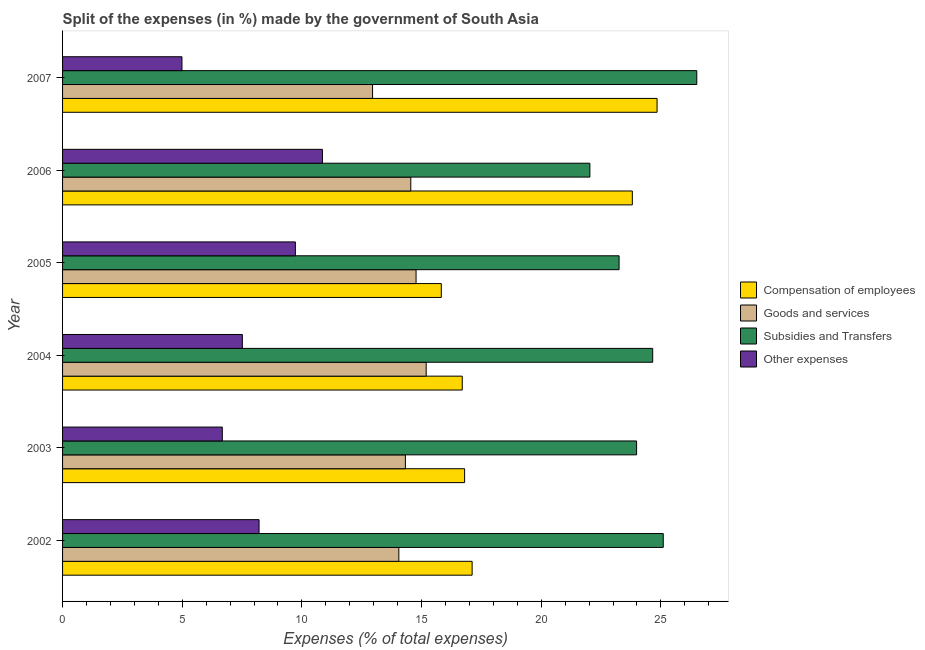How many different coloured bars are there?
Ensure brevity in your answer.  4. Are the number of bars per tick equal to the number of legend labels?
Keep it short and to the point. Yes. How many bars are there on the 3rd tick from the top?
Your answer should be compact. 4. In how many cases, is the number of bars for a given year not equal to the number of legend labels?
Ensure brevity in your answer.  0. What is the percentage of amount spent on goods and services in 2003?
Offer a very short reply. 14.32. Across all years, what is the maximum percentage of amount spent on subsidies?
Your answer should be compact. 26.5. Across all years, what is the minimum percentage of amount spent on compensation of employees?
Offer a very short reply. 15.82. In which year was the percentage of amount spent on compensation of employees maximum?
Make the answer very short. 2007. In which year was the percentage of amount spent on subsidies minimum?
Provide a succinct answer. 2006. What is the total percentage of amount spent on subsidies in the graph?
Provide a succinct answer. 145.52. What is the difference between the percentage of amount spent on goods and services in 2004 and that in 2006?
Ensure brevity in your answer.  0.64. What is the difference between the percentage of amount spent on subsidies in 2006 and the percentage of amount spent on other expenses in 2002?
Ensure brevity in your answer.  13.82. What is the average percentage of amount spent on other expenses per year?
Your answer should be compact. 8. In the year 2007, what is the difference between the percentage of amount spent on compensation of employees and percentage of amount spent on other expenses?
Provide a short and direct response. 19.85. What is the ratio of the percentage of amount spent on subsidies in 2004 to that in 2005?
Your answer should be very brief. 1.06. What is the difference between the highest and the second highest percentage of amount spent on other expenses?
Provide a short and direct response. 1.13. What is the difference between the highest and the lowest percentage of amount spent on subsidies?
Your answer should be very brief. 4.47. Is the sum of the percentage of amount spent on goods and services in 2006 and 2007 greater than the maximum percentage of amount spent on subsidies across all years?
Make the answer very short. Yes. Is it the case that in every year, the sum of the percentage of amount spent on goods and services and percentage of amount spent on subsidies is greater than the sum of percentage of amount spent on compensation of employees and percentage of amount spent on other expenses?
Your response must be concise. No. What does the 3rd bar from the top in 2002 represents?
Provide a short and direct response. Goods and services. What does the 4th bar from the bottom in 2002 represents?
Give a very brief answer. Other expenses. Is it the case that in every year, the sum of the percentage of amount spent on compensation of employees and percentage of amount spent on goods and services is greater than the percentage of amount spent on subsidies?
Make the answer very short. Yes. Are all the bars in the graph horizontal?
Provide a short and direct response. Yes. How many years are there in the graph?
Make the answer very short. 6. Does the graph contain any zero values?
Keep it short and to the point. No. Does the graph contain grids?
Offer a terse response. No. How are the legend labels stacked?
Ensure brevity in your answer.  Vertical. What is the title of the graph?
Offer a very short reply. Split of the expenses (in %) made by the government of South Asia. What is the label or title of the X-axis?
Keep it short and to the point. Expenses (% of total expenses). What is the Expenses (% of total expenses) of Compensation of employees in 2002?
Offer a very short reply. 17.11. What is the Expenses (% of total expenses) of Goods and services in 2002?
Provide a short and direct response. 14.05. What is the Expenses (% of total expenses) of Subsidies and Transfers in 2002?
Give a very brief answer. 25.1. What is the Expenses (% of total expenses) in Other expenses in 2002?
Provide a succinct answer. 8.21. What is the Expenses (% of total expenses) in Compensation of employees in 2003?
Offer a terse response. 16.8. What is the Expenses (% of total expenses) in Goods and services in 2003?
Ensure brevity in your answer.  14.32. What is the Expenses (% of total expenses) in Subsidies and Transfers in 2003?
Give a very brief answer. 23.98. What is the Expenses (% of total expenses) of Other expenses in 2003?
Keep it short and to the point. 6.67. What is the Expenses (% of total expenses) in Compensation of employees in 2004?
Provide a succinct answer. 16.7. What is the Expenses (% of total expenses) of Goods and services in 2004?
Offer a very short reply. 15.19. What is the Expenses (% of total expenses) in Subsidies and Transfers in 2004?
Keep it short and to the point. 24.66. What is the Expenses (% of total expenses) of Other expenses in 2004?
Make the answer very short. 7.51. What is the Expenses (% of total expenses) in Compensation of employees in 2005?
Provide a succinct answer. 15.82. What is the Expenses (% of total expenses) of Goods and services in 2005?
Make the answer very short. 14.77. What is the Expenses (% of total expenses) of Subsidies and Transfers in 2005?
Provide a succinct answer. 23.25. What is the Expenses (% of total expenses) of Other expenses in 2005?
Offer a very short reply. 9.73. What is the Expenses (% of total expenses) in Compensation of employees in 2006?
Offer a very short reply. 23.81. What is the Expenses (% of total expenses) in Goods and services in 2006?
Your response must be concise. 14.55. What is the Expenses (% of total expenses) in Subsidies and Transfers in 2006?
Provide a succinct answer. 22.03. What is the Expenses (% of total expenses) in Other expenses in 2006?
Your answer should be compact. 10.86. What is the Expenses (% of total expenses) of Compensation of employees in 2007?
Make the answer very short. 24.84. What is the Expenses (% of total expenses) in Goods and services in 2007?
Your answer should be compact. 12.95. What is the Expenses (% of total expenses) in Subsidies and Transfers in 2007?
Your response must be concise. 26.5. What is the Expenses (% of total expenses) in Other expenses in 2007?
Offer a very short reply. 4.99. Across all years, what is the maximum Expenses (% of total expenses) of Compensation of employees?
Your response must be concise. 24.84. Across all years, what is the maximum Expenses (% of total expenses) of Goods and services?
Provide a succinct answer. 15.19. Across all years, what is the maximum Expenses (% of total expenses) in Subsidies and Transfers?
Provide a short and direct response. 26.5. Across all years, what is the maximum Expenses (% of total expenses) in Other expenses?
Provide a succinct answer. 10.86. Across all years, what is the minimum Expenses (% of total expenses) of Compensation of employees?
Give a very brief answer. 15.82. Across all years, what is the minimum Expenses (% of total expenses) in Goods and services?
Offer a very short reply. 12.95. Across all years, what is the minimum Expenses (% of total expenses) of Subsidies and Transfers?
Make the answer very short. 22.03. Across all years, what is the minimum Expenses (% of total expenses) of Other expenses?
Give a very brief answer. 4.99. What is the total Expenses (% of total expenses) of Compensation of employees in the graph?
Offer a terse response. 115.08. What is the total Expenses (% of total expenses) in Goods and services in the graph?
Give a very brief answer. 85.84. What is the total Expenses (% of total expenses) of Subsidies and Transfers in the graph?
Give a very brief answer. 145.52. What is the total Expenses (% of total expenses) of Other expenses in the graph?
Your response must be concise. 47.97. What is the difference between the Expenses (% of total expenses) of Compensation of employees in 2002 and that in 2003?
Provide a succinct answer. 0.31. What is the difference between the Expenses (% of total expenses) of Goods and services in 2002 and that in 2003?
Keep it short and to the point. -0.27. What is the difference between the Expenses (% of total expenses) in Subsidies and Transfers in 2002 and that in 2003?
Make the answer very short. 1.11. What is the difference between the Expenses (% of total expenses) of Other expenses in 2002 and that in 2003?
Offer a very short reply. 1.54. What is the difference between the Expenses (% of total expenses) of Compensation of employees in 2002 and that in 2004?
Keep it short and to the point. 0.41. What is the difference between the Expenses (% of total expenses) of Goods and services in 2002 and that in 2004?
Your answer should be compact. -1.14. What is the difference between the Expenses (% of total expenses) in Subsidies and Transfers in 2002 and that in 2004?
Provide a succinct answer. 0.44. What is the difference between the Expenses (% of total expenses) of Other expenses in 2002 and that in 2004?
Make the answer very short. 0.7. What is the difference between the Expenses (% of total expenses) of Compensation of employees in 2002 and that in 2005?
Your answer should be very brief. 1.29. What is the difference between the Expenses (% of total expenses) in Goods and services in 2002 and that in 2005?
Your response must be concise. -0.72. What is the difference between the Expenses (% of total expenses) in Subsidies and Transfers in 2002 and that in 2005?
Make the answer very short. 1.84. What is the difference between the Expenses (% of total expenses) in Other expenses in 2002 and that in 2005?
Make the answer very short. -1.52. What is the difference between the Expenses (% of total expenses) in Compensation of employees in 2002 and that in 2006?
Ensure brevity in your answer.  -6.69. What is the difference between the Expenses (% of total expenses) of Goods and services in 2002 and that in 2006?
Provide a short and direct response. -0.5. What is the difference between the Expenses (% of total expenses) of Subsidies and Transfers in 2002 and that in 2006?
Your answer should be compact. 3.07. What is the difference between the Expenses (% of total expenses) in Other expenses in 2002 and that in 2006?
Your answer should be very brief. -2.65. What is the difference between the Expenses (% of total expenses) of Compensation of employees in 2002 and that in 2007?
Ensure brevity in your answer.  -7.73. What is the difference between the Expenses (% of total expenses) in Goods and services in 2002 and that in 2007?
Your answer should be very brief. 1.1. What is the difference between the Expenses (% of total expenses) of Subsidies and Transfers in 2002 and that in 2007?
Ensure brevity in your answer.  -1.4. What is the difference between the Expenses (% of total expenses) of Other expenses in 2002 and that in 2007?
Make the answer very short. 3.22. What is the difference between the Expenses (% of total expenses) in Compensation of employees in 2003 and that in 2004?
Offer a terse response. 0.1. What is the difference between the Expenses (% of total expenses) in Goods and services in 2003 and that in 2004?
Ensure brevity in your answer.  -0.87. What is the difference between the Expenses (% of total expenses) of Subsidies and Transfers in 2003 and that in 2004?
Ensure brevity in your answer.  -0.67. What is the difference between the Expenses (% of total expenses) in Other expenses in 2003 and that in 2004?
Your answer should be compact. -0.84. What is the difference between the Expenses (% of total expenses) of Compensation of employees in 2003 and that in 2005?
Keep it short and to the point. 0.97. What is the difference between the Expenses (% of total expenses) of Goods and services in 2003 and that in 2005?
Your response must be concise. -0.45. What is the difference between the Expenses (% of total expenses) of Subsidies and Transfers in 2003 and that in 2005?
Give a very brief answer. 0.73. What is the difference between the Expenses (% of total expenses) of Other expenses in 2003 and that in 2005?
Ensure brevity in your answer.  -3.05. What is the difference between the Expenses (% of total expenses) of Compensation of employees in 2003 and that in 2006?
Keep it short and to the point. -7.01. What is the difference between the Expenses (% of total expenses) of Goods and services in 2003 and that in 2006?
Offer a terse response. -0.23. What is the difference between the Expenses (% of total expenses) in Subsidies and Transfers in 2003 and that in 2006?
Your answer should be very brief. 1.95. What is the difference between the Expenses (% of total expenses) of Other expenses in 2003 and that in 2006?
Your answer should be very brief. -4.18. What is the difference between the Expenses (% of total expenses) in Compensation of employees in 2003 and that in 2007?
Your answer should be compact. -8.04. What is the difference between the Expenses (% of total expenses) in Goods and services in 2003 and that in 2007?
Keep it short and to the point. 1.37. What is the difference between the Expenses (% of total expenses) in Subsidies and Transfers in 2003 and that in 2007?
Make the answer very short. -2.52. What is the difference between the Expenses (% of total expenses) of Other expenses in 2003 and that in 2007?
Ensure brevity in your answer.  1.69. What is the difference between the Expenses (% of total expenses) of Compensation of employees in 2004 and that in 2005?
Offer a very short reply. 0.88. What is the difference between the Expenses (% of total expenses) of Goods and services in 2004 and that in 2005?
Your answer should be very brief. 0.42. What is the difference between the Expenses (% of total expenses) of Subsidies and Transfers in 2004 and that in 2005?
Offer a very short reply. 1.4. What is the difference between the Expenses (% of total expenses) of Other expenses in 2004 and that in 2005?
Give a very brief answer. -2.22. What is the difference between the Expenses (% of total expenses) of Compensation of employees in 2004 and that in 2006?
Keep it short and to the point. -7.11. What is the difference between the Expenses (% of total expenses) of Goods and services in 2004 and that in 2006?
Ensure brevity in your answer.  0.64. What is the difference between the Expenses (% of total expenses) of Subsidies and Transfers in 2004 and that in 2006?
Give a very brief answer. 2.63. What is the difference between the Expenses (% of total expenses) in Other expenses in 2004 and that in 2006?
Keep it short and to the point. -3.35. What is the difference between the Expenses (% of total expenses) of Compensation of employees in 2004 and that in 2007?
Offer a very short reply. -8.14. What is the difference between the Expenses (% of total expenses) of Goods and services in 2004 and that in 2007?
Give a very brief answer. 2.24. What is the difference between the Expenses (% of total expenses) of Subsidies and Transfers in 2004 and that in 2007?
Your answer should be very brief. -1.84. What is the difference between the Expenses (% of total expenses) in Other expenses in 2004 and that in 2007?
Your answer should be compact. 2.52. What is the difference between the Expenses (% of total expenses) in Compensation of employees in 2005 and that in 2006?
Offer a very short reply. -7.98. What is the difference between the Expenses (% of total expenses) in Goods and services in 2005 and that in 2006?
Provide a short and direct response. 0.22. What is the difference between the Expenses (% of total expenses) in Subsidies and Transfers in 2005 and that in 2006?
Your answer should be compact. 1.22. What is the difference between the Expenses (% of total expenses) of Other expenses in 2005 and that in 2006?
Make the answer very short. -1.13. What is the difference between the Expenses (% of total expenses) in Compensation of employees in 2005 and that in 2007?
Provide a succinct answer. -9.02. What is the difference between the Expenses (% of total expenses) in Goods and services in 2005 and that in 2007?
Give a very brief answer. 1.82. What is the difference between the Expenses (% of total expenses) in Subsidies and Transfers in 2005 and that in 2007?
Your response must be concise. -3.25. What is the difference between the Expenses (% of total expenses) of Other expenses in 2005 and that in 2007?
Your response must be concise. 4.74. What is the difference between the Expenses (% of total expenses) of Compensation of employees in 2006 and that in 2007?
Provide a succinct answer. -1.03. What is the difference between the Expenses (% of total expenses) in Goods and services in 2006 and that in 2007?
Offer a very short reply. 1.6. What is the difference between the Expenses (% of total expenses) of Subsidies and Transfers in 2006 and that in 2007?
Provide a succinct answer. -4.47. What is the difference between the Expenses (% of total expenses) of Other expenses in 2006 and that in 2007?
Your response must be concise. 5.87. What is the difference between the Expenses (% of total expenses) of Compensation of employees in 2002 and the Expenses (% of total expenses) of Goods and services in 2003?
Ensure brevity in your answer.  2.79. What is the difference between the Expenses (% of total expenses) of Compensation of employees in 2002 and the Expenses (% of total expenses) of Subsidies and Transfers in 2003?
Your answer should be very brief. -6.87. What is the difference between the Expenses (% of total expenses) in Compensation of employees in 2002 and the Expenses (% of total expenses) in Other expenses in 2003?
Provide a short and direct response. 10.44. What is the difference between the Expenses (% of total expenses) of Goods and services in 2002 and the Expenses (% of total expenses) of Subsidies and Transfers in 2003?
Your response must be concise. -9.93. What is the difference between the Expenses (% of total expenses) of Goods and services in 2002 and the Expenses (% of total expenses) of Other expenses in 2003?
Make the answer very short. 7.38. What is the difference between the Expenses (% of total expenses) in Subsidies and Transfers in 2002 and the Expenses (% of total expenses) in Other expenses in 2003?
Provide a succinct answer. 18.42. What is the difference between the Expenses (% of total expenses) of Compensation of employees in 2002 and the Expenses (% of total expenses) of Goods and services in 2004?
Offer a very short reply. 1.92. What is the difference between the Expenses (% of total expenses) of Compensation of employees in 2002 and the Expenses (% of total expenses) of Subsidies and Transfers in 2004?
Give a very brief answer. -7.54. What is the difference between the Expenses (% of total expenses) in Compensation of employees in 2002 and the Expenses (% of total expenses) in Other expenses in 2004?
Your response must be concise. 9.6. What is the difference between the Expenses (% of total expenses) of Goods and services in 2002 and the Expenses (% of total expenses) of Subsidies and Transfers in 2004?
Offer a very short reply. -10.61. What is the difference between the Expenses (% of total expenses) of Goods and services in 2002 and the Expenses (% of total expenses) of Other expenses in 2004?
Provide a succinct answer. 6.54. What is the difference between the Expenses (% of total expenses) of Subsidies and Transfers in 2002 and the Expenses (% of total expenses) of Other expenses in 2004?
Ensure brevity in your answer.  17.59. What is the difference between the Expenses (% of total expenses) of Compensation of employees in 2002 and the Expenses (% of total expenses) of Goods and services in 2005?
Keep it short and to the point. 2.34. What is the difference between the Expenses (% of total expenses) in Compensation of employees in 2002 and the Expenses (% of total expenses) in Subsidies and Transfers in 2005?
Provide a short and direct response. -6.14. What is the difference between the Expenses (% of total expenses) in Compensation of employees in 2002 and the Expenses (% of total expenses) in Other expenses in 2005?
Provide a short and direct response. 7.38. What is the difference between the Expenses (% of total expenses) of Goods and services in 2002 and the Expenses (% of total expenses) of Subsidies and Transfers in 2005?
Your response must be concise. -9.2. What is the difference between the Expenses (% of total expenses) in Goods and services in 2002 and the Expenses (% of total expenses) in Other expenses in 2005?
Give a very brief answer. 4.32. What is the difference between the Expenses (% of total expenses) in Subsidies and Transfers in 2002 and the Expenses (% of total expenses) in Other expenses in 2005?
Your answer should be very brief. 15.37. What is the difference between the Expenses (% of total expenses) in Compensation of employees in 2002 and the Expenses (% of total expenses) in Goods and services in 2006?
Offer a very short reply. 2.56. What is the difference between the Expenses (% of total expenses) of Compensation of employees in 2002 and the Expenses (% of total expenses) of Subsidies and Transfers in 2006?
Offer a very short reply. -4.92. What is the difference between the Expenses (% of total expenses) of Compensation of employees in 2002 and the Expenses (% of total expenses) of Other expenses in 2006?
Provide a short and direct response. 6.25. What is the difference between the Expenses (% of total expenses) of Goods and services in 2002 and the Expenses (% of total expenses) of Subsidies and Transfers in 2006?
Offer a terse response. -7.98. What is the difference between the Expenses (% of total expenses) of Goods and services in 2002 and the Expenses (% of total expenses) of Other expenses in 2006?
Keep it short and to the point. 3.19. What is the difference between the Expenses (% of total expenses) of Subsidies and Transfers in 2002 and the Expenses (% of total expenses) of Other expenses in 2006?
Give a very brief answer. 14.24. What is the difference between the Expenses (% of total expenses) of Compensation of employees in 2002 and the Expenses (% of total expenses) of Goods and services in 2007?
Your answer should be compact. 4.16. What is the difference between the Expenses (% of total expenses) in Compensation of employees in 2002 and the Expenses (% of total expenses) in Subsidies and Transfers in 2007?
Provide a succinct answer. -9.39. What is the difference between the Expenses (% of total expenses) in Compensation of employees in 2002 and the Expenses (% of total expenses) in Other expenses in 2007?
Offer a terse response. 12.12. What is the difference between the Expenses (% of total expenses) of Goods and services in 2002 and the Expenses (% of total expenses) of Subsidies and Transfers in 2007?
Offer a very short reply. -12.45. What is the difference between the Expenses (% of total expenses) of Goods and services in 2002 and the Expenses (% of total expenses) of Other expenses in 2007?
Provide a short and direct response. 9.06. What is the difference between the Expenses (% of total expenses) of Subsidies and Transfers in 2002 and the Expenses (% of total expenses) of Other expenses in 2007?
Provide a succinct answer. 20.11. What is the difference between the Expenses (% of total expenses) of Compensation of employees in 2003 and the Expenses (% of total expenses) of Goods and services in 2004?
Ensure brevity in your answer.  1.6. What is the difference between the Expenses (% of total expenses) in Compensation of employees in 2003 and the Expenses (% of total expenses) in Subsidies and Transfers in 2004?
Ensure brevity in your answer.  -7.86. What is the difference between the Expenses (% of total expenses) in Compensation of employees in 2003 and the Expenses (% of total expenses) in Other expenses in 2004?
Your response must be concise. 9.29. What is the difference between the Expenses (% of total expenses) of Goods and services in 2003 and the Expenses (% of total expenses) of Subsidies and Transfers in 2004?
Ensure brevity in your answer.  -10.33. What is the difference between the Expenses (% of total expenses) in Goods and services in 2003 and the Expenses (% of total expenses) in Other expenses in 2004?
Offer a terse response. 6.81. What is the difference between the Expenses (% of total expenses) in Subsidies and Transfers in 2003 and the Expenses (% of total expenses) in Other expenses in 2004?
Provide a succinct answer. 16.47. What is the difference between the Expenses (% of total expenses) of Compensation of employees in 2003 and the Expenses (% of total expenses) of Goods and services in 2005?
Ensure brevity in your answer.  2.03. What is the difference between the Expenses (% of total expenses) in Compensation of employees in 2003 and the Expenses (% of total expenses) in Subsidies and Transfers in 2005?
Your response must be concise. -6.45. What is the difference between the Expenses (% of total expenses) in Compensation of employees in 2003 and the Expenses (% of total expenses) in Other expenses in 2005?
Give a very brief answer. 7.07. What is the difference between the Expenses (% of total expenses) in Goods and services in 2003 and the Expenses (% of total expenses) in Subsidies and Transfers in 2005?
Offer a terse response. -8.93. What is the difference between the Expenses (% of total expenses) in Goods and services in 2003 and the Expenses (% of total expenses) in Other expenses in 2005?
Offer a terse response. 4.6. What is the difference between the Expenses (% of total expenses) in Subsidies and Transfers in 2003 and the Expenses (% of total expenses) in Other expenses in 2005?
Offer a terse response. 14.26. What is the difference between the Expenses (% of total expenses) in Compensation of employees in 2003 and the Expenses (% of total expenses) in Goods and services in 2006?
Your answer should be very brief. 2.25. What is the difference between the Expenses (% of total expenses) of Compensation of employees in 2003 and the Expenses (% of total expenses) of Subsidies and Transfers in 2006?
Your answer should be compact. -5.23. What is the difference between the Expenses (% of total expenses) in Compensation of employees in 2003 and the Expenses (% of total expenses) in Other expenses in 2006?
Provide a succinct answer. 5.94. What is the difference between the Expenses (% of total expenses) of Goods and services in 2003 and the Expenses (% of total expenses) of Subsidies and Transfers in 2006?
Ensure brevity in your answer.  -7.71. What is the difference between the Expenses (% of total expenses) of Goods and services in 2003 and the Expenses (% of total expenses) of Other expenses in 2006?
Provide a short and direct response. 3.47. What is the difference between the Expenses (% of total expenses) in Subsidies and Transfers in 2003 and the Expenses (% of total expenses) in Other expenses in 2006?
Your answer should be very brief. 13.12. What is the difference between the Expenses (% of total expenses) of Compensation of employees in 2003 and the Expenses (% of total expenses) of Goods and services in 2007?
Provide a succinct answer. 3.85. What is the difference between the Expenses (% of total expenses) in Compensation of employees in 2003 and the Expenses (% of total expenses) in Subsidies and Transfers in 2007?
Offer a terse response. -9.7. What is the difference between the Expenses (% of total expenses) in Compensation of employees in 2003 and the Expenses (% of total expenses) in Other expenses in 2007?
Your response must be concise. 11.81. What is the difference between the Expenses (% of total expenses) in Goods and services in 2003 and the Expenses (% of total expenses) in Subsidies and Transfers in 2007?
Provide a succinct answer. -12.18. What is the difference between the Expenses (% of total expenses) in Goods and services in 2003 and the Expenses (% of total expenses) in Other expenses in 2007?
Give a very brief answer. 9.34. What is the difference between the Expenses (% of total expenses) of Subsidies and Transfers in 2003 and the Expenses (% of total expenses) of Other expenses in 2007?
Keep it short and to the point. 19. What is the difference between the Expenses (% of total expenses) of Compensation of employees in 2004 and the Expenses (% of total expenses) of Goods and services in 2005?
Offer a very short reply. 1.93. What is the difference between the Expenses (% of total expenses) in Compensation of employees in 2004 and the Expenses (% of total expenses) in Subsidies and Transfers in 2005?
Your answer should be compact. -6.55. What is the difference between the Expenses (% of total expenses) in Compensation of employees in 2004 and the Expenses (% of total expenses) in Other expenses in 2005?
Ensure brevity in your answer.  6.97. What is the difference between the Expenses (% of total expenses) of Goods and services in 2004 and the Expenses (% of total expenses) of Subsidies and Transfers in 2005?
Ensure brevity in your answer.  -8.06. What is the difference between the Expenses (% of total expenses) in Goods and services in 2004 and the Expenses (% of total expenses) in Other expenses in 2005?
Your response must be concise. 5.47. What is the difference between the Expenses (% of total expenses) in Subsidies and Transfers in 2004 and the Expenses (% of total expenses) in Other expenses in 2005?
Keep it short and to the point. 14.93. What is the difference between the Expenses (% of total expenses) in Compensation of employees in 2004 and the Expenses (% of total expenses) in Goods and services in 2006?
Your response must be concise. 2.15. What is the difference between the Expenses (% of total expenses) in Compensation of employees in 2004 and the Expenses (% of total expenses) in Subsidies and Transfers in 2006?
Offer a terse response. -5.33. What is the difference between the Expenses (% of total expenses) of Compensation of employees in 2004 and the Expenses (% of total expenses) of Other expenses in 2006?
Give a very brief answer. 5.84. What is the difference between the Expenses (% of total expenses) of Goods and services in 2004 and the Expenses (% of total expenses) of Subsidies and Transfers in 2006?
Your answer should be very brief. -6.84. What is the difference between the Expenses (% of total expenses) of Goods and services in 2004 and the Expenses (% of total expenses) of Other expenses in 2006?
Provide a succinct answer. 4.33. What is the difference between the Expenses (% of total expenses) in Subsidies and Transfers in 2004 and the Expenses (% of total expenses) in Other expenses in 2006?
Your answer should be compact. 13.8. What is the difference between the Expenses (% of total expenses) in Compensation of employees in 2004 and the Expenses (% of total expenses) in Goods and services in 2007?
Your answer should be very brief. 3.75. What is the difference between the Expenses (% of total expenses) of Compensation of employees in 2004 and the Expenses (% of total expenses) of Subsidies and Transfers in 2007?
Keep it short and to the point. -9.8. What is the difference between the Expenses (% of total expenses) of Compensation of employees in 2004 and the Expenses (% of total expenses) of Other expenses in 2007?
Give a very brief answer. 11.71. What is the difference between the Expenses (% of total expenses) of Goods and services in 2004 and the Expenses (% of total expenses) of Subsidies and Transfers in 2007?
Your response must be concise. -11.31. What is the difference between the Expenses (% of total expenses) of Goods and services in 2004 and the Expenses (% of total expenses) of Other expenses in 2007?
Ensure brevity in your answer.  10.2. What is the difference between the Expenses (% of total expenses) of Subsidies and Transfers in 2004 and the Expenses (% of total expenses) of Other expenses in 2007?
Give a very brief answer. 19.67. What is the difference between the Expenses (% of total expenses) in Compensation of employees in 2005 and the Expenses (% of total expenses) in Goods and services in 2006?
Make the answer very short. 1.27. What is the difference between the Expenses (% of total expenses) of Compensation of employees in 2005 and the Expenses (% of total expenses) of Subsidies and Transfers in 2006?
Your response must be concise. -6.21. What is the difference between the Expenses (% of total expenses) of Compensation of employees in 2005 and the Expenses (% of total expenses) of Other expenses in 2006?
Keep it short and to the point. 4.96. What is the difference between the Expenses (% of total expenses) in Goods and services in 2005 and the Expenses (% of total expenses) in Subsidies and Transfers in 2006?
Offer a very short reply. -7.26. What is the difference between the Expenses (% of total expenses) in Goods and services in 2005 and the Expenses (% of total expenses) in Other expenses in 2006?
Provide a succinct answer. 3.91. What is the difference between the Expenses (% of total expenses) of Subsidies and Transfers in 2005 and the Expenses (% of total expenses) of Other expenses in 2006?
Make the answer very short. 12.39. What is the difference between the Expenses (% of total expenses) of Compensation of employees in 2005 and the Expenses (% of total expenses) of Goods and services in 2007?
Offer a very short reply. 2.87. What is the difference between the Expenses (% of total expenses) in Compensation of employees in 2005 and the Expenses (% of total expenses) in Subsidies and Transfers in 2007?
Offer a terse response. -10.68. What is the difference between the Expenses (% of total expenses) in Compensation of employees in 2005 and the Expenses (% of total expenses) in Other expenses in 2007?
Your answer should be compact. 10.84. What is the difference between the Expenses (% of total expenses) in Goods and services in 2005 and the Expenses (% of total expenses) in Subsidies and Transfers in 2007?
Offer a very short reply. -11.73. What is the difference between the Expenses (% of total expenses) in Goods and services in 2005 and the Expenses (% of total expenses) in Other expenses in 2007?
Your answer should be very brief. 9.78. What is the difference between the Expenses (% of total expenses) of Subsidies and Transfers in 2005 and the Expenses (% of total expenses) of Other expenses in 2007?
Your answer should be very brief. 18.26. What is the difference between the Expenses (% of total expenses) of Compensation of employees in 2006 and the Expenses (% of total expenses) of Goods and services in 2007?
Your response must be concise. 10.85. What is the difference between the Expenses (% of total expenses) of Compensation of employees in 2006 and the Expenses (% of total expenses) of Subsidies and Transfers in 2007?
Your answer should be very brief. -2.69. What is the difference between the Expenses (% of total expenses) of Compensation of employees in 2006 and the Expenses (% of total expenses) of Other expenses in 2007?
Your response must be concise. 18.82. What is the difference between the Expenses (% of total expenses) in Goods and services in 2006 and the Expenses (% of total expenses) in Subsidies and Transfers in 2007?
Offer a very short reply. -11.95. What is the difference between the Expenses (% of total expenses) of Goods and services in 2006 and the Expenses (% of total expenses) of Other expenses in 2007?
Provide a short and direct response. 9.56. What is the difference between the Expenses (% of total expenses) of Subsidies and Transfers in 2006 and the Expenses (% of total expenses) of Other expenses in 2007?
Your response must be concise. 17.04. What is the average Expenses (% of total expenses) of Compensation of employees per year?
Provide a short and direct response. 19.18. What is the average Expenses (% of total expenses) of Goods and services per year?
Make the answer very short. 14.31. What is the average Expenses (% of total expenses) in Subsidies and Transfers per year?
Keep it short and to the point. 24.25. What is the average Expenses (% of total expenses) of Other expenses per year?
Make the answer very short. 7.99. In the year 2002, what is the difference between the Expenses (% of total expenses) in Compensation of employees and Expenses (% of total expenses) in Goods and services?
Your answer should be compact. 3.06. In the year 2002, what is the difference between the Expenses (% of total expenses) of Compensation of employees and Expenses (% of total expenses) of Subsidies and Transfers?
Offer a very short reply. -7.99. In the year 2002, what is the difference between the Expenses (% of total expenses) of Compensation of employees and Expenses (% of total expenses) of Other expenses?
Ensure brevity in your answer.  8.9. In the year 2002, what is the difference between the Expenses (% of total expenses) in Goods and services and Expenses (% of total expenses) in Subsidies and Transfers?
Your answer should be very brief. -11.05. In the year 2002, what is the difference between the Expenses (% of total expenses) of Goods and services and Expenses (% of total expenses) of Other expenses?
Give a very brief answer. 5.84. In the year 2002, what is the difference between the Expenses (% of total expenses) of Subsidies and Transfers and Expenses (% of total expenses) of Other expenses?
Give a very brief answer. 16.89. In the year 2003, what is the difference between the Expenses (% of total expenses) of Compensation of employees and Expenses (% of total expenses) of Goods and services?
Give a very brief answer. 2.47. In the year 2003, what is the difference between the Expenses (% of total expenses) in Compensation of employees and Expenses (% of total expenses) in Subsidies and Transfers?
Your answer should be very brief. -7.19. In the year 2003, what is the difference between the Expenses (% of total expenses) of Compensation of employees and Expenses (% of total expenses) of Other expenses?
Make the answer very short. 10.12. In the year 2003, what is the difference between the Expenses (% of total expenses) in Goods and services and Expenses (% of total expenses) in Subsidies and Transfers?
Give a very brief answer. -9.66. In the year 2003, what is the difference between the Expenses (% of total expenses) of Goods and services and Expenses (% of total expenses) of Other expenses?
Offer a terse response. 7.65. In the year 2003, what is the difference between the Expenses (% of total expenses) in Subsidies and Transfers and Expenses (% of total expenses) in Other expenses?
Offer a terse response. 17.31. In the year 2004, what is the difference between the Expenses (% of total expenses) of Compensation of employees and Expenses (% of total expenses) of Goods and services?
Provide a succinct answer. 1.51. In the year 2004, what is the difference between the Expenses (% of total expenses) of Compensation of employees and Expenses (% of total expenses) of Subsidies and Transfers?
Offer a terse response. -7.96. In the year 2004, what is the difference between the Expenses (% of total expenses) of Compensation of employees and Expenses (% of total expenses) of Other expenses?
Give a very brief answer. 9.19. In the year 2004, what is the difference between the Expenses (% of total expenses) in Goods and services and Expenses (% of total expenses) in Subsidies and Transfers?
Make the answer very short. -9.46. In the year 2004, what is the difference between the Expenses (% of total expenses) in Goods and services and Expenses (% of total expenses) in Other expenses?
Provide a succinct answer. 7.68. In the year 2004, what is the difference between the Expenses (% of total expenses) of Subsidies and Transfers and Expenses (% of total expenses) of Other expenses?
Offer a terse response. 17.14. In the year 2005, what is the difference between the Expenses (% of total expenses) of Compensation of employees and Expenses (% of total expenses) of Goods and services?
Offer a very short reply. 1.05. In the year 2005, what is the difference between the Expenses (% of total expenses) of Compensation of employees and Expenses (% of total expenses) of Subsidies and Transfers?
Your response must be concise. -7.43. In the year 2005, what is the difference between the Expenses (% of total expenses) in Compensation of employees and Expenses (% of total expenses) in Other expenses?
Keep it short and to the point. 6.1. In the year 2005, what is the difference between the Expenses (% of total expenses) of Goods and services and Expenses (% of total expenses) of Subsidies and Transfers?
Ensure brevity in your answer.  -8.48. In the year 2005, what is the difference between the Expenses (% of total expenses) of Goods and services and Expenses (% of total expenses) of Other expenses?
Make the answer very short. 5.04. In the year 2005, what is the difference between the Expenses (% of total expenses) of Subsidies and Transfers and Expenses (% of total expenses) of Other expenses?
Your response must be concise. 13.53. In the year 2006, what is the difference between the Expenses (% of total expenses) in Compensation of employees and Expenses (% of total expenses) in Goods and services?
Ensure brevity in your answer.  9.26. In the year 2006, what is the difference between the Expenses (% of total expenses) in Compensation of employees and Expenses (% of total expenses) in Subsidies and Transfers?
Offer a very short reply. 1.77. In the year 2006, what is the difference between the Expenses (% of total expenses) of Compensation of employees and Expenses (% of total expenses) of Other expenses?
Provide a short and direct response. 12.95. In the year 2006, what is the difference between the Expenses (% of total expenses) in Goods and services and Expenses (% of total expenses) in Subsidies and Transfers?
Your response must be concise. -7.48. In the year 2006, what is the difference between the Expenses (% of total expenses) in Goods and services and Expenses (% of total expenses) in Other expenses?
Keep it short and to the point. 3.69. In the year 2006, what is the difference between the Expenses (% of total expenses) of Subsidies and Transfers and Expenses (% of total expenses) of Other expenses?
Your answer should be very brief. 11.17. In the year 2007, what is the difference between the Expenses (% of total expenses) of Compensation of employees and Expenses (% of total expenses) of Goods and services?
Make the answer very short. 11.89. In the year 2007, what is the difference between the Expenses (% of total expenses) in Compensation of employees and Expenses (% of total expenses) in Subsidies and Transfers?
Keep it short and to the point. -1.66. In the year 2007, what is the difference between the Expenses (% of total expenses) in Compensation of employees and Expenses (% of total expenses) in Other expenses?
Provide a short and direct response. 19.85. In the year 2007, what is the difference between the Expenses (% of total expenses) in Goods and services and Expenses (% of total expenses) in Subsidies and Transfers?
Provide a succinct answer. -13.55. In the year 2007, what is the difference between the Expenses (% of total expenses) in Goods and services and Expenses (% of total expenses) in Other expenses?
Your answer should be compact. 7.96. In the year 2007, what is the difference between the Expenses (% of total expenses) in Subsidies and Transfers and Expenses (% of total expenses) in Other expenses?
Offer a very short reply. 21.51. What is the ratio of the Expenses (% of total expenses) of Compensation of employees in 2002 to that in 2003?
Ensure brevity in your answer.  1.02. What is the ratio of the Expenses (% of total expenses) in Goods and services in 2002 to that in 2003?
Your response must be concise. 0.98. What is the ratio of the Expenses (% of total expenses) in Subsidies and Transfers in 2002 to that in 2003?
Offer a very short reply. 1.05. What is the ratio of the Expenses (% of total expenses) in Other expenses in 2002 to that in 2003?
Provide a succinct answer. 1.23. What is the ratio of the Expenses (% of total expenses) in Compensation of employees in 2002 to that in 2004?
Ensure brevity in your answer.  1.02. What is the ratio of the Expenses (% of total expenses) of Goods and services in 2002 to that in 2004?
Your answer should be very brief. 0.92. What is the ratio of the Expenses (% of total expenses) in Subsidies and Transfers in 2002 to that in 2004?
Offer a terse response. 1.02. What is the ratio of the Expenses (% of total expenses) of Other expenses in 2002 to that in 2004?
Ensure brevity in your answer.  1.09. What is the ratio of the Expenses (% of total expenses) of Compensation of employees in 2002 to that in 2005?
Your response must be concise. 1.08. What is the ratio of the Expenses (% of total expenses) in Goods and services in 2002 to that in 2005?
Your answer should be very brief. 0.95. What is the ratio of the Expenses (% of total expenses) of Subsidies and Transfers in 2002 to that in 2005?
Offer a terse response. 1.08. What is the ratio of the Expenses (% of total expenses) of Other expenses in 2002 to that in 2005?
Ensure brevity in your answer.  0.84. What is the ratio of the Expenses (% of total expenses) of Compensation of employees in 2002 to that in 2006?
Provide a succinct answer. 0.72. What is the ratio of the Expenses (% of total expenses) in Goods and services in 2002 to that in 2006?
Your response must be concise. 0.97. What is the ratio of the Expenses (% of total expenses) of Subsidies and Transfers in 2002 to that in 2006?
Offer a terse response. 1.14. What is the ratio of the Expenses (% of total expenses) of Other expenses in 2002 to that in 2006?
Keep it short and to the point. 0.76. What is the ratio of the Expenses (% of total expenses) of Compensation of employees in 2002 to that in 2007?
Your answer should be very brief. 0.69. What is the ratio of the Expenses (% of total expenses) of Goods and services in 2002 to that in 2007?
Your answer should be compact. 1.08. What is the ratio of the Expenses (% of total expenses) in Subsidies and Transfers in 2002 to that in 2007?
Your answer should be compact. 0.95. What is the ratio of the Expenses (% of total expenses) of Other expenses in 2002 to that in 2007?
Keep it short and to the point. 1.65. What is the ratio of the Expenses (% of total expenses) in Compensation of employees in 2003 to that in 2004?
Provide a short and direct response. 1.01. What is the ratio of the Expenses (% of total expenses) of Goods and services in 2003 to that in 2004?
Offer a very short reply. 0.94. What is the ratio of the Expenses (% of total expenses) of Subsidies and Transfers in 2003 to that in 2004?
Your response must be concise. 0.97. What is the ratio of the Expenses (% of total expenses) of Other expenses in 2003 to that in 2004?
Provide a short and direct response. 0.89. What is the ratio of the Expenses (% of total expenses) in Compensation of employees in 2003 to that in 2005?
Offer a very short reply. 1.06. What is the ratio of the Expenses (% of total expenses) in Goods and services in 2003 to that in 2005?
Make the answer very short. 0.97. What is the ratio of the Expenses (% of total expenses) in Subsidies and Transfers in 2003 to that in 2005?
Provide a short and direct response. 1.03. What is the ratio of the Expenses (% of total expenses) of Other expenses in 2003 to that in 2005?
Your answer should be very brief. 0.69. What is the ratio of the Expenses (% of total expenses) in Compensation of employees in 2003 to that in 2006?
Offer a terse response. 0.71. What is the ratio of the Expenses (% of total expenses) in Goods and services in 2003 to that in 2006?
Your answer should be compact. 0.98. What is the ratio of the Expenses (% of total expenses) in Subsidies and Transfers in 2003 to that in 2006?
Make the answer very short. 1.09. What is the ratio of the Expenses (% of total expenses) in Other expenses in 2003 to that in 2006?
Ensure brevity in your answer.  0.61. What is the ratio of the Expenses (% of total expenses) in Compensation of employees in 2003 to that in 2007?
Provide a succinct answer. 0.68. What is the ratio of the Expenses (% of total expenses) of Goods and services in 2003 to that in 2007?
Make the answer very short. 1.11. What is the ratio of the Expenses (% of total expenses) in Subsidies and Transfers in 2003 to that in 2007?
Ensure brevity in your answer.  0.91. What is the ratio of the Expenses (% of total expenses) of Other expenses in 2003 to that in 2007?
Offer a terse response. 1.34. What is the ratio of the Expenses (% of total expenses) in Compensation of employees in 2004 to that in 2005?
Your response must be concise. 1.06. What is the ratio of the Expenses (% of total expenses) in Goods and services in 2004 to that in 2005?
Keep it short and to the point. 1.03. What is the ratio of the Expenses (% of total expenses) in Subsidies and Transfers in 2004 to that in 2005?
Your answer should be very brief. 1.06. What is the ratio of the Expenses (% of total expenses) of Other expenses in 2004 to that in 2005?
Provide a succinct answer. 0.77. What is the ratio of the Expenses (% of total expenses) of Compensation of employees in 2004 to that in 2006?
Offer a terse response. 0.7. What is the ratio of the Expenses (% of total expenses) of Goods and services in 2004 to that in 2006?
Your answer should be very brief. 1.04. What is the ratio of the Expenses (% of total expenses) in Subsidies and Transfers in 2004 to that in 2006?
Keep it short and to the point. 1.12. What is the ratio of the Expenses (% of total expenses) in Other expenses in 2004 to that in 2006?
Make the answer very short. 0.69. What is the ratio of the Expenses (% of total expenses) in Compensation of employees in 2004 to that in 2007?
Your response must be concise. 0.67. What is the ratio of the Expenses (% of total expenses) in Goods and services in 2004 to that in 2007?
Your response must be concise. 1.17. What is the ratio of the Expenses (% of total expenses) in Subsidies and Transfers in 2004 to that in 2007?
Offer a terse response. 0.93. What is the ratio of the Expenses (% of total expenses) in Other expenses in 2004 to that in 2007?
Your answer should be very brief. 1.51. What is the ratio of the Expenses (% of total expenses) of Compensation of employees in 2005 to that in 2006?
Your answer should be compact. 0.66. What is the ratio of the Expenses (% of total expenses) of Goods and services in 2005 to that in 2006?
Offer a terse response. 1.02. What is the ratio of the Expenses (% of total expenses) of Subsidies and Transfers in 2005 to that in 2006?
Provide a short and direct response. 1.06. What is the ratio of the Expenses (% of total expenses) in Other expenses in 2005 to that in 2006?
Offer a terse response. 0.9. What is the ratio of the Expenses (% of total expenses) in Compensation of employees in 2005 to that in 2007?
Provide a succinct answer. 0.64. What is the ratio of the Expenses (% of total expenses) in Goods and services in 2005 to that in 2007?
Offer a very short reply. 1.14. What is the ratio of the Expenses (% of total expenses) of Subsidies and Transfers in 2005 to that in 2007?
Offer a very short reply. 0.88. What is the ratio of the Expenses (% of total expenses) of Other expenses in 2005 to that in 2007?
Offer a very short reply. 1.95. What is the ratio of the Expenses (% of total expenses) of Compensation of employees in 2006 to that in 2007?
Offer a very short reply. 0.96. What is the ratio of the Expenses (% of total expenses) of Goods and services in 2006 to that in 2007?
Give a very brief answer. 1.12. What is the ratio of the Expenses (% of total expenses) of Subsidies and Transfers in 2006 to that in 2007?
Give a very brief answer. 0.83. What is the ratio of the Expenses (% of total expenses) of Other expenses in 2006 to that in 2007?
Keep it short and to the point. 2.18. What is the difference between the highest and the second highest Expenses (% of total expenses) of Compensation of employees?
Keep it short and to the point. 1.03. What is the difference between the highest and the second highest Expenses (% of total expenses) of Goods and services?
Provide a short and direct response. 0.42. What is the difference between the highest and the second highest Expenses (% of total expenses) of Subsidies and Transfers?
Ensure brevity in your answer.  1.4. What is the difference between the highest and the second highest Expenses (% of total expenses) in Other expenses?
Provide a succinct answer. 1.13. What is the difference between the highest and the lowest Expenses (% of total expenses) of Compensation of employees?
Your response must be concise. 9.02. What is the difference between the highest and the lowest Expenses (% of total expenses) in Goods and services?
Your answer should be compact. 2.24. What is the difference between the highest and the lowest Expenses (% of total expenses) of Subsidies and Transfers?
Provide a succinct answer. 4.47. What is the difference between the highest and the lowest Expenses (% of total expenses) of Other expenses?
Keep it short and to the point. 5.87. 